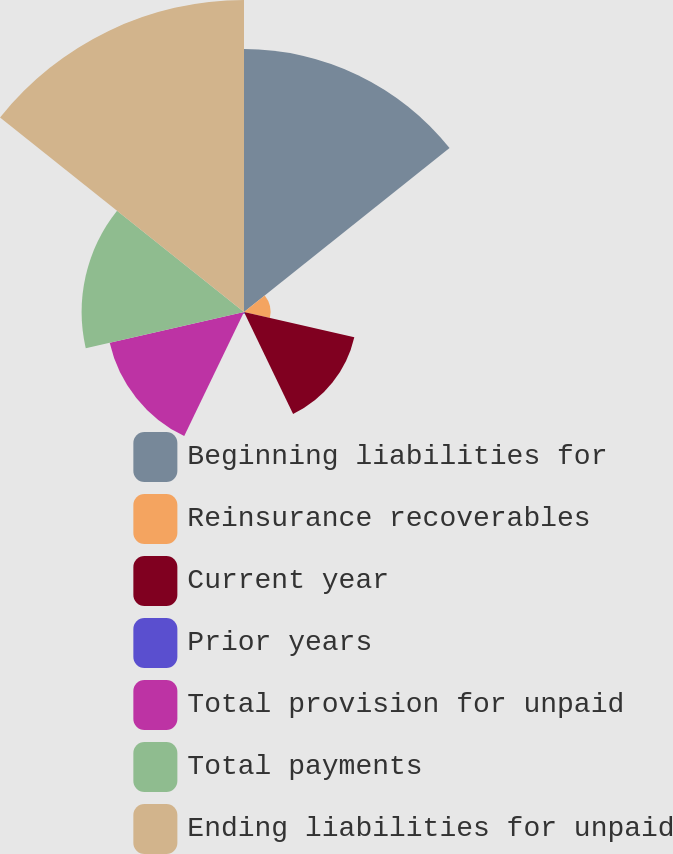Convert chart to OTSL. <chart><loc_0><loc_0><loc_500><loc_500><pie_chart><fcel>Beginning liabilities for<fcel>Reinsurance recoverables<fcel>Current year<fcel>Prior years<fcel>Total provision for unpaid<fcel>Total payments<fcel>Ending liabilities for unpaid<nl><fcel>25.86%<fcel>2.61%<fcel>11.13%<fcel>0.19%<fcel>13.55%<fcel>15.97%<fcel>30.69%<nl></chart> 